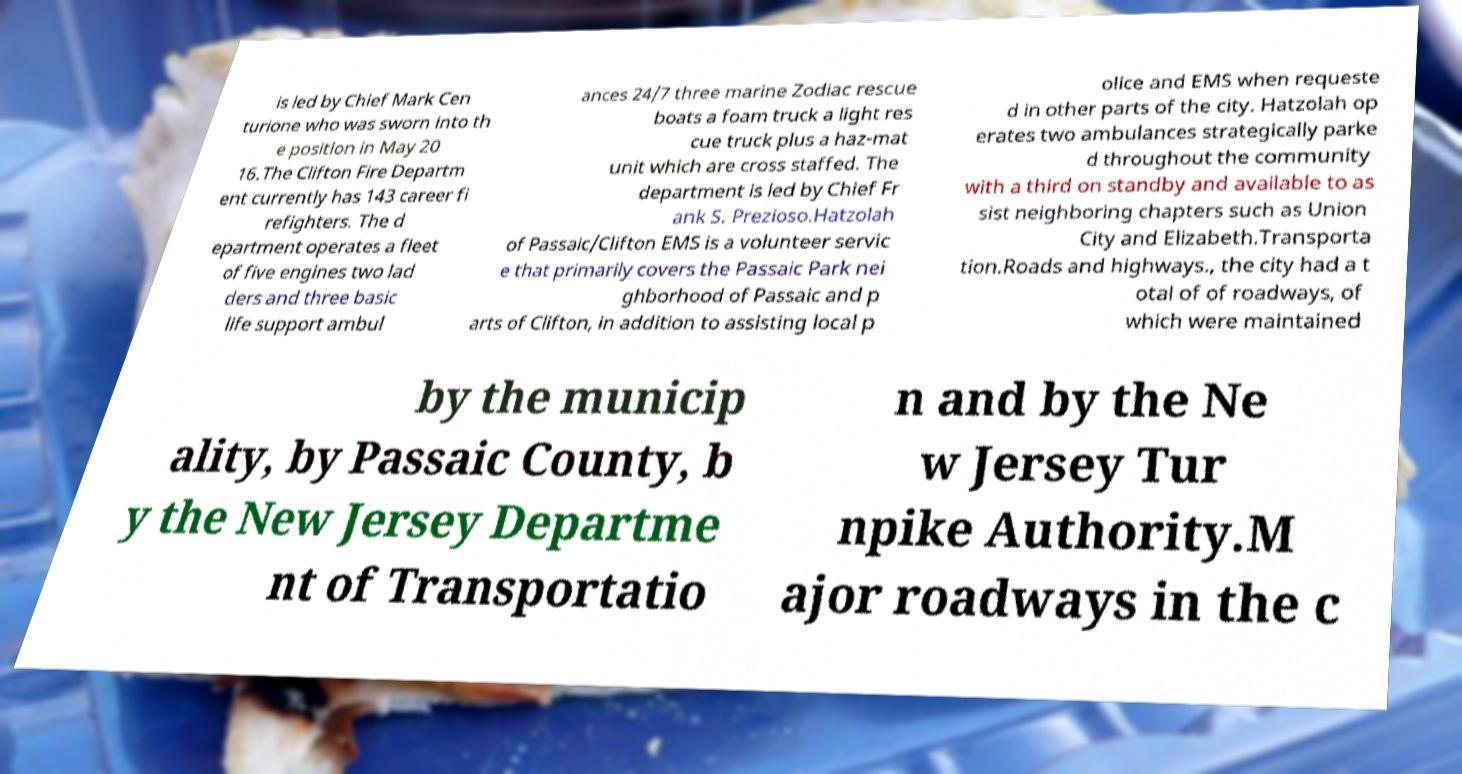There's text embedded in this image that I need extracted. Can you transcribe it verbatim? is led by Chief Mark Cen turione who was sworn into th e position in May 20 16.The Clifton Fire Departm ent currently has 143 career fi refighters. The d epartment operates a fleet of five engines two lad ders and three basic life support ambul ances 24/7 three marine Zodiac rescue boats a foam truck a light res cue truck plus a haz-mat unit which are cross staffed. The department is led by Chief Fr ank S. Prezioso.Hatzolah of Passaic/Clifton EMS is a volunteer servic e that primarily covers the Passaic Park nei ghborhood of Passaic and p arts of Clifton, in addition to assisting local p olice and EMS when requeste d in other parts of the city. Hatzolah op erates two ambulances strategically parke d throughout the community with a third on standby and available to as sist neighboring chapters such as Union City and Elizabeth.Transporta tion.Roads and highways., the city had a t otal of of roadways, of which were maintained by the municip ality, by Passaic County, b y the New Jersey Departme nt of Transportatio n and by the Ne w Jersey Tur npike Authority.M ajor roadways in the c 